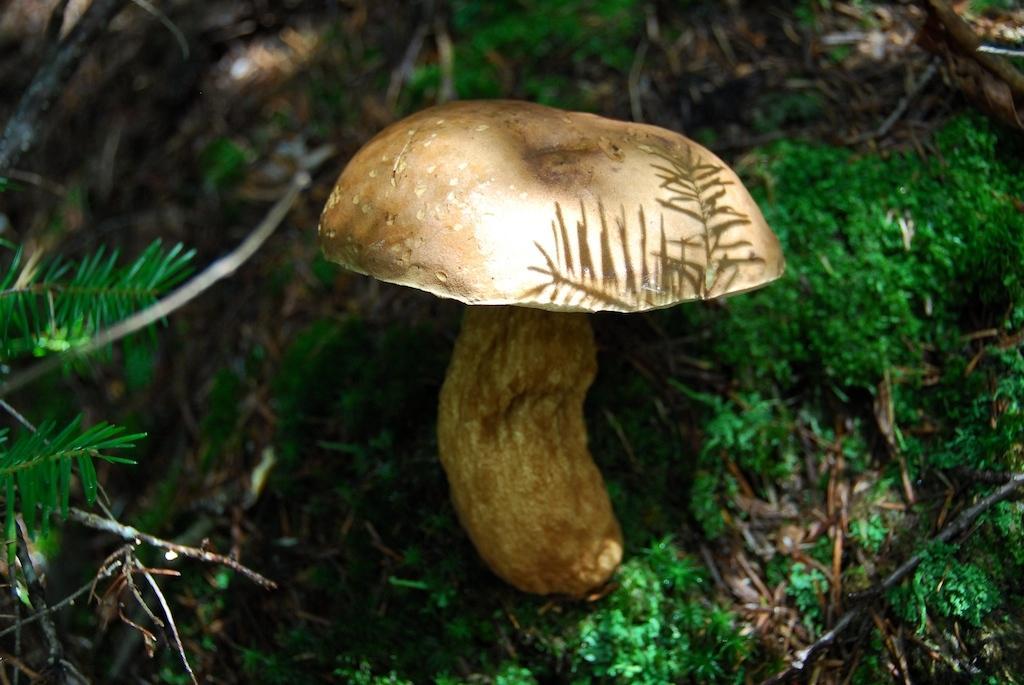Please provide a concise description of this image. In this image in the center there is a mushroom, and at the bottom there is grass and plants. 